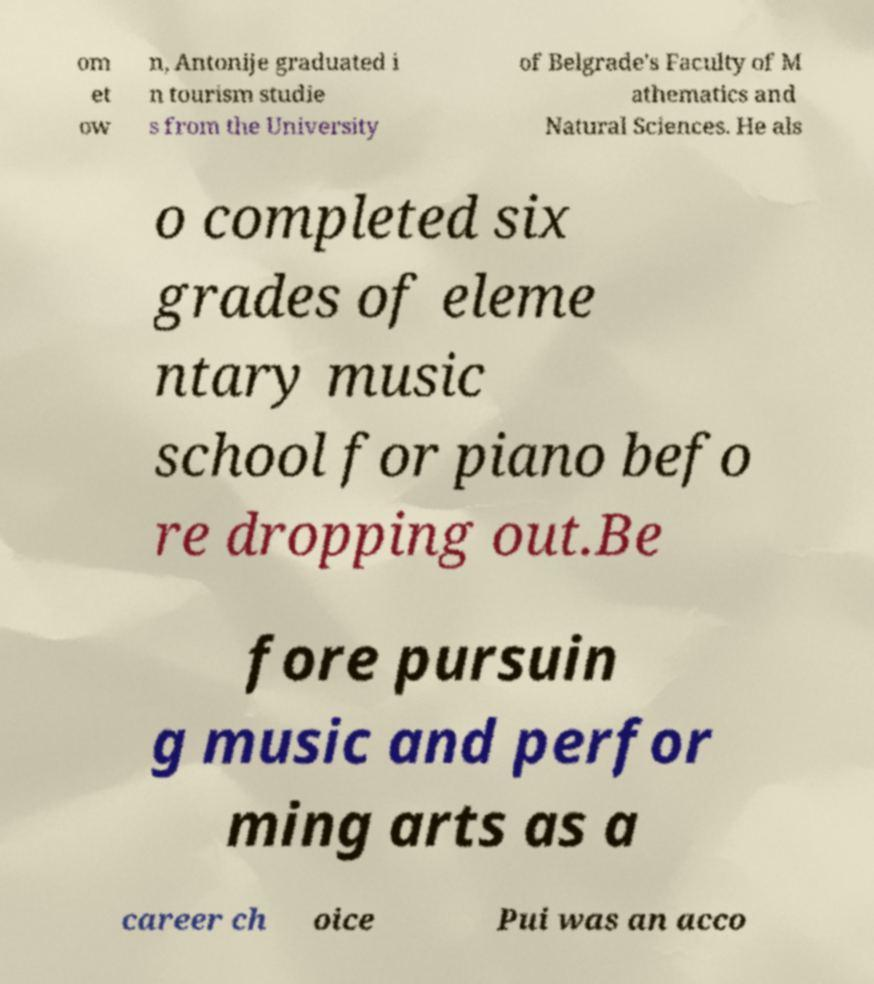Please read and relay the text visible in this image. What does it say? om et ow n, Antonije graduated i n tourism studie s from the University of Belgrade's Faculty of M athematics and Natural Sciences. He als o completed six grades of eleme ntary music school for piano befo re dropping out.Be fore pursuin g music and perfor ming arts as a career ch oice Pui was an acco 